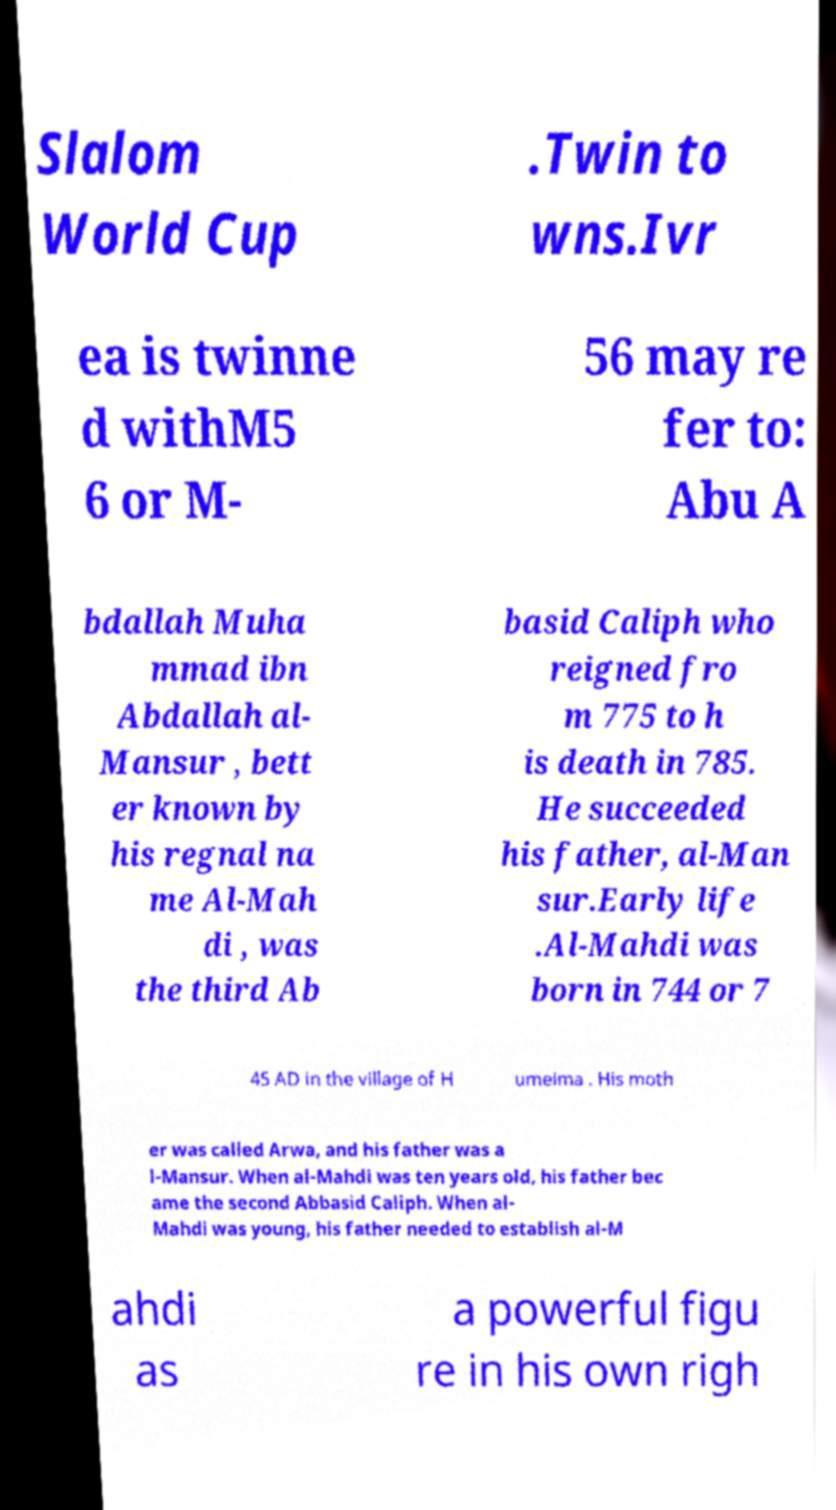For documentation purposes, I need the text within this image transcribed. Could you provide that? Slalom World Cup .Twin to wns.Ivr ea is twinne d withM5 6 or M- 56 may re fer to: Abu A bdallah Muha mmad ibn Abdallah al- Mansur , bett er known by his regnal na me Al-Mah di , was the third Ab basid Caliph who reigned fro m 775 to h is death in 785. He succeeded his father, al-Man sur.Early life .Al-Mahdi was born in 744 or 7 45 AD in the village of H umeima . His moth er was called Arwa, and his father was a l-Mansur. When al-Mahdi was ten years old, his father bec ame the second Abbasid Caliph. When al- Mahdi was young, his father needed to establish al-M ahdi as a powerful figu re in his own righ 